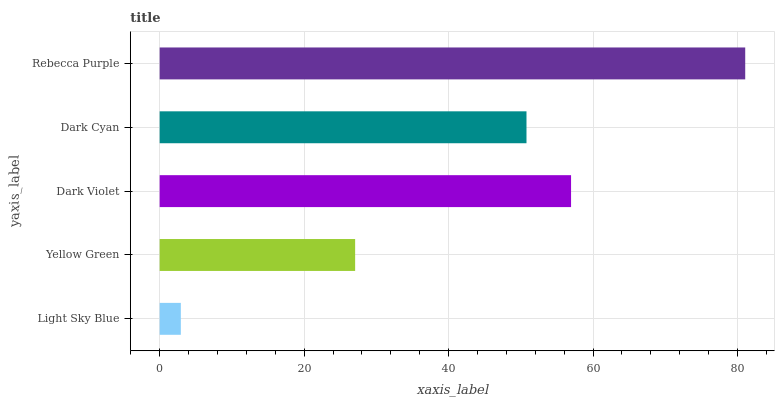Is Light Sky Blue the minimum?
Answer yes or no. Yes. Is Rebecca Purple the maximum?
Answer yes or no. Yes. Is Yellow Green the minimum?
Answer yes or no. No. Is Yellow Green the maximum?
Answer yes or no. No. Is Yellow Green greater than Light Sky Blue?
Answer yes or no. Yes. Is Light Sky Blue less than Yellow Green?
Answer yes or no. Yes. Is Light Sky Blue greater than Yellow Green?
Answer yes or no. No. Is Yellow Green less than Light Sky Blue?
Answer yes or no. No. Is Dark Cyan the high median?
Answer yes or no. Yes. Is Dark Cyan the low median?
Answer yes or no. Yes. Is Dark Violet the high median?
Answer yes or no. No. Is Yellow Green the low median?
Answer yes or no. No. 